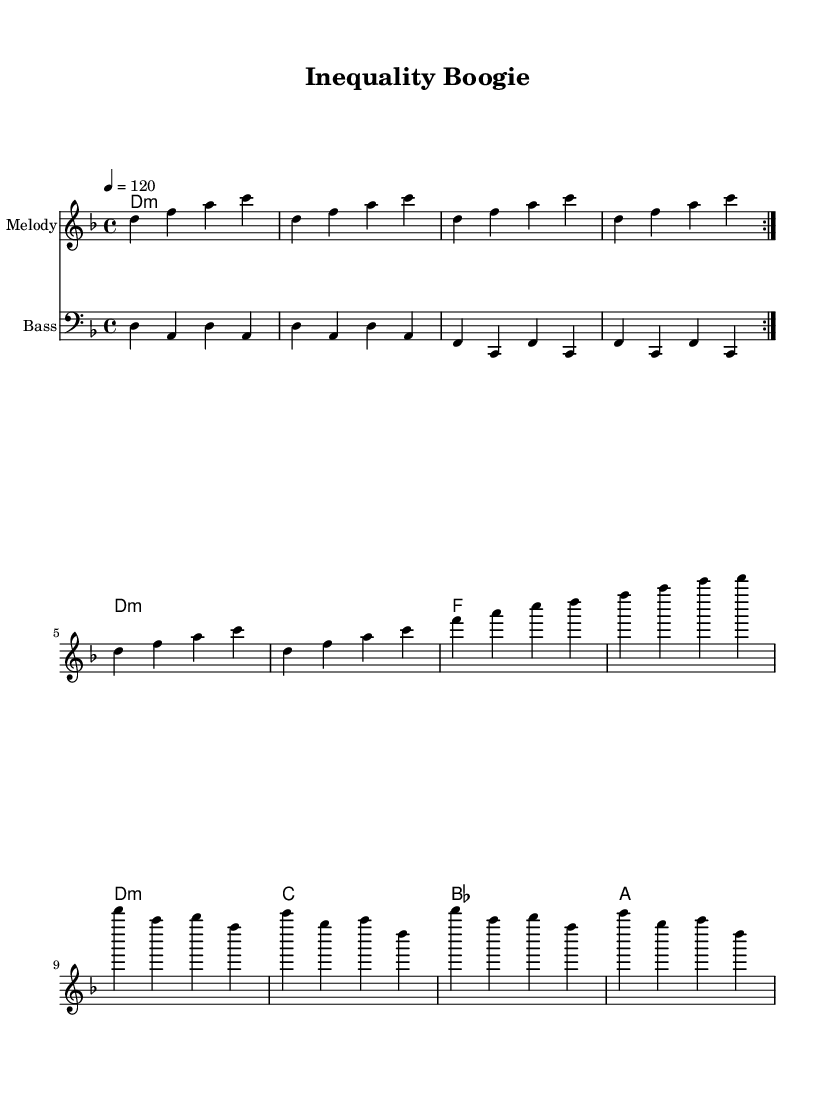What is the key signature of this music? The key signature is D minor, which is indicated by the two flats in the key signature (B flat and E flat).
Answer: D minor What is the time signature of the piece? The time signature is 4/4, which means there are four beats per measure, and the quarter note gets one beat. This is denoted at the beginning of the score.
Answer: 4/4 What is the tempo marking of the piece? The tempo marking is a quarter note equals 120 beats per minute, indicated above the staff in the score.
Answer: 120 How many times is the first melody section repeated? The first melody section is marked to be repeated 2 times, indicated by the volta marking that appears above the repeat signs.
Answer: 2 What chord is played for the longest duration in the harmonies section? The chord D minor is held for the longest duration since it lasts for four measures as a whole note, with no other chords holding that duration.
Answer: D minor How many unique chords are present in the harmonies section? The harmonies section contains four unique chords: D minor, F major, C major, and B flat major, which can be counted as they alternate throughout the section.
Answer: 4 What instrument is indicated for the melody staff? The instrument indicated for the melody staff is referred to as "Melody," noted above the staff, which is typically a lead instrument in disco music.
Answer: Melody 